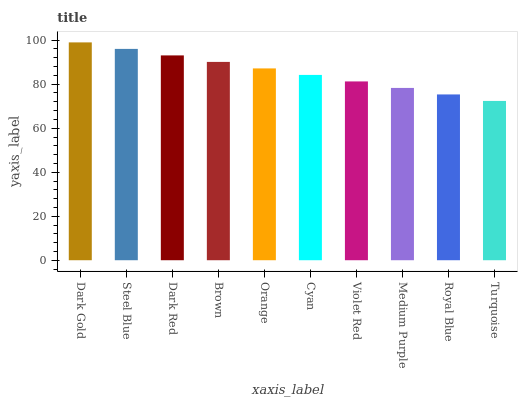Is Steel Blue the minimum?
Answer yes or no. No. Is Steel Blue the maximum?
Answer yes or no. No. Is Dark Gold greater than Steel Blue?
Answer yes or no. Yes. Is Steel Blue less than Dark Gold?
Answer yes or no. Yes. Is Steel Blue greater than Dark Gold?
Answer yes or no. No. Is Dark Gold less than Steel Blue?
Answer yes or no. No. Is Orange the high median?
Answer yes or no. Yes. Is Cyan the low median?
Answer yes or no. Yes. Is Violet Red the high median?
Answer yes or no. No. Is Turquoise the low median?
Answer yes or no. No. 